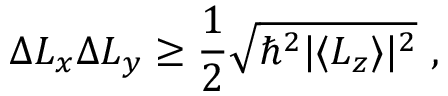Convert formula to latex. <formula><loc_0><loc_0><loc_500><loc_500>\Delta L _ { x } \Delta L _ { y } \geq { \frac { 1 } { 2 } } { \sqrt { \hbar { ^ } { 2 } | \langle L _ { z } \rangle | ^ { 2 } } } ,</formula> 